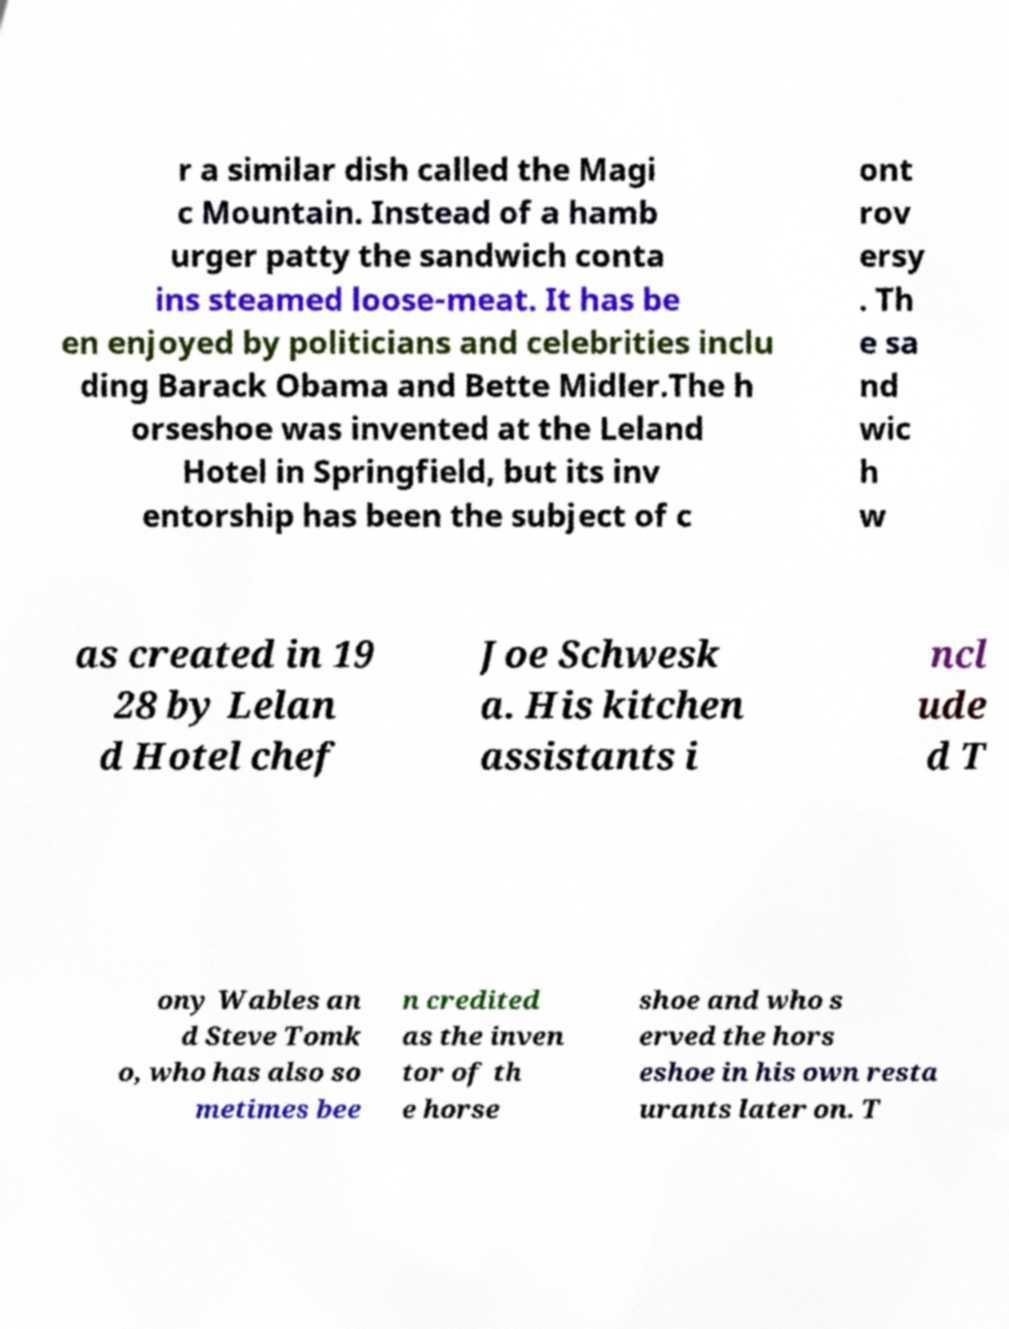There's text embedded in this image that I need extracted. Can you transcribe it verbatim? r a similar dish called the Magi c Mountain. Instead of a hamb urger patty the sandwich conta ins steamed loose-meat. It has be en enjoyed by politicians and celebrities inclu ding Barack Obama and Bette Midler.The h orseshoe was invented at the Leland Hotel in Springfield, but its inv entorship has been the subject of c ont rov ersy . Th e sa nd wic h w as created in 19 28 by Lelan d Hotel chef Joe Schwesk a. His kitchen assistants i ncl ude d T ony Wables an d Steve Tomk o, who has also so metimes bee n credited as the inven tor of th e horse shoe and who s erved the hors eshoe in his own resta urants later on. T 